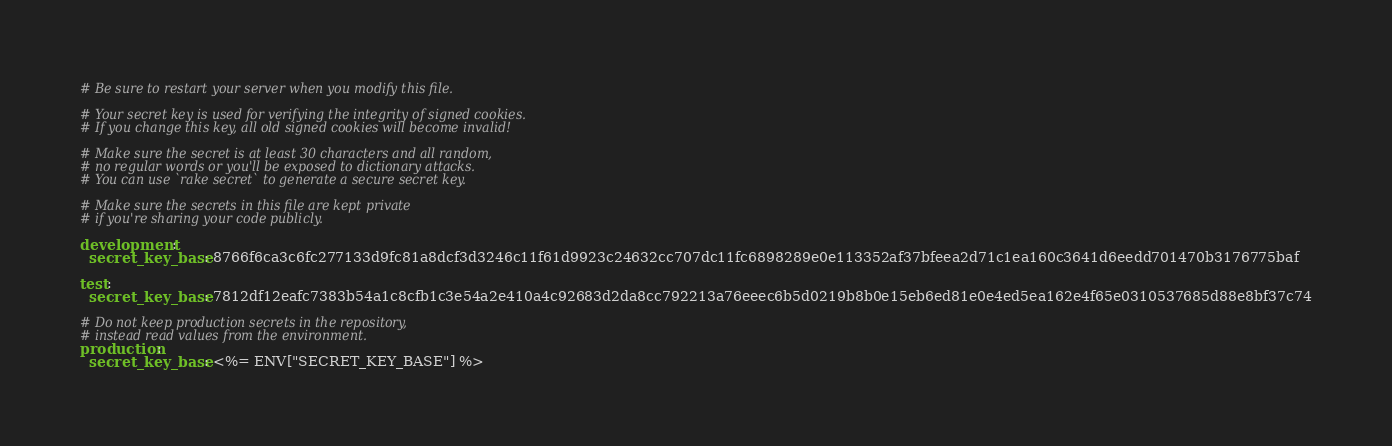Convert code to text. <code><loc_0><loc_0><loc_500><loc_500><_YAML_># Be sure to restart your server when you modify this file.

# Your secret key is used for verifying the integrity of signed cookies.
# If you change this key, all old signed cookies will become invalid!

# Make sure the secret is at least 30 characters and all random,
# no regular words or you'll be exposed to dictionary attacks.
# You can use `rake secret` to generate a secure secret key.

# Make sure the secrets in this file are kept private
# if you're sharing your code publicly.

development:
  secret_key_base: 8766f6ca3c6fc277133d9fc81a8dcf3d3246c11f61d9923c24632cc707dc11fc6898289e0e113352af37bfeea2d71c1ea160c3641d6eedd701470b3176775baf

test:
  secret_key_base: 7812df12eafc7383b54a1c8cfb1c3e54a2e410a4c92683d2da8cc792213a76eeec6b5d0219b8b0e15eb6ed81e0e4ed5ea162e4f65e0310537685d88e8bf37c74

# Do not keep production secrets in the repository,
# instead read values from the environment.
production:
  secret_key_base: <%= ENV["SECRET_KEY_BASE"] %>
</code> 